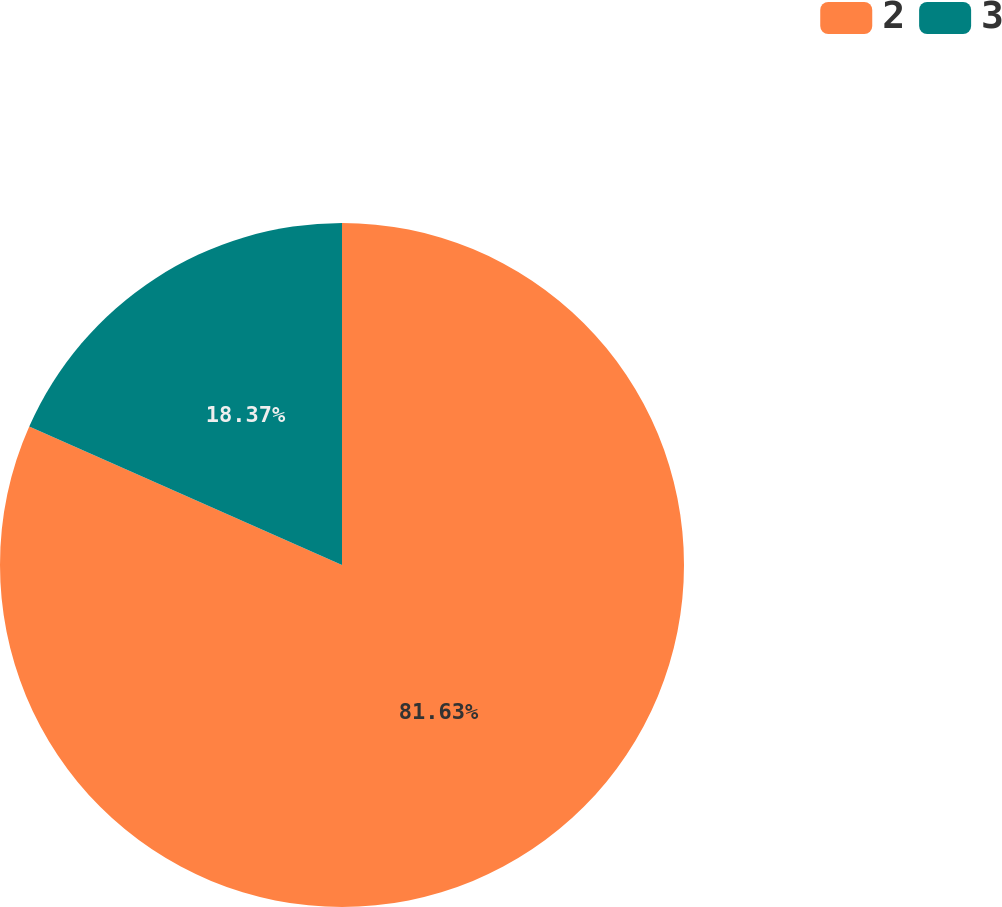Convert chart. <chart><loc_0><loc_0><loc_500><loc_500><pie_chart><fcel>2<fcel>3<nl><fcel>81.63%<fcel>18.37%<nl></chart> 